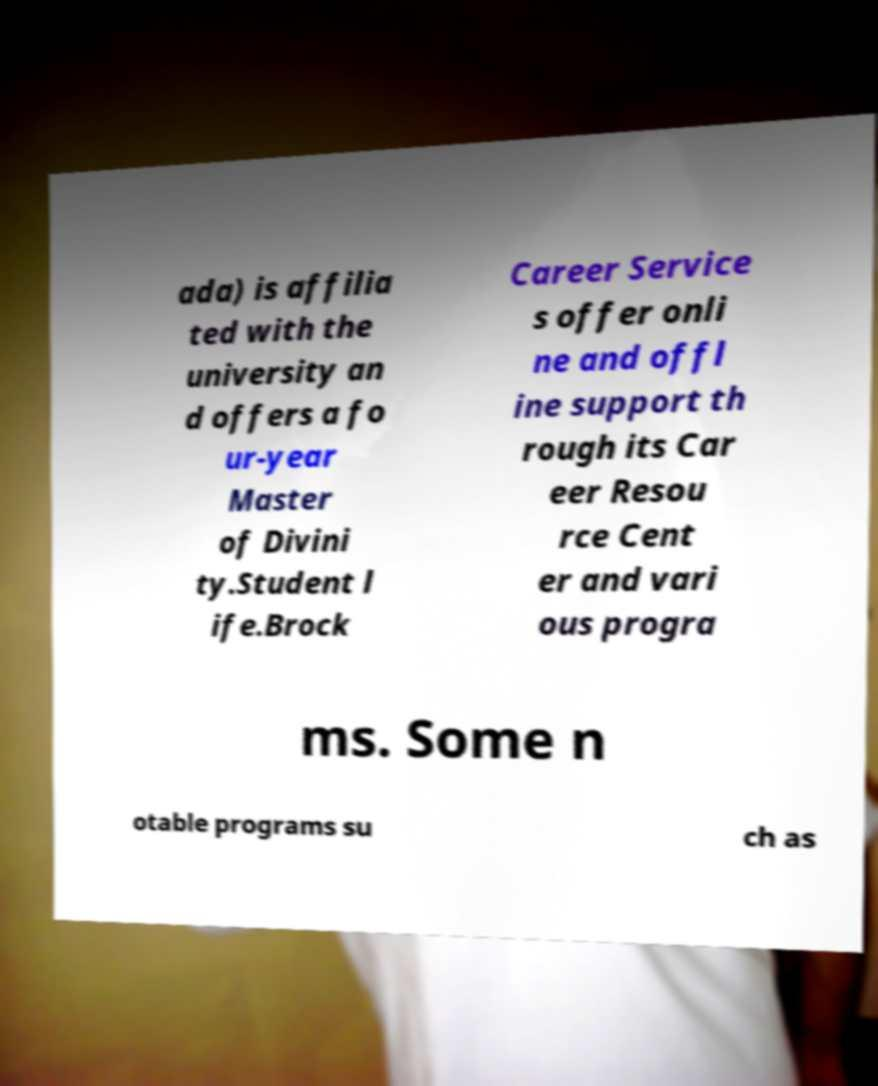What messages or text are displayed in this image? I need them in a readable, typed format. ada) is affilia ted with the university an d offers a fo ur-year Master of Divini ty.Student l ife.Brock Career Service s offer onli ne and offl ine support th rough its Car eer Resou rce Cent er and vari ous progra ms. Some n otable programs su ch as 